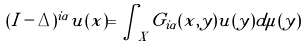Convert formula to latex. <formula><loc_0><loc_0><loc_500><loc_500>( I - \Delta ) ^ { i \alpha } u ( x ) = \int _ { X } G _ { i \alpha } ( x , y ) u ( y ) d \mu ( y )</formula> 